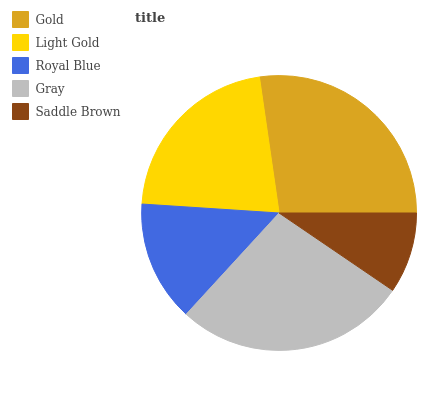Is Saddle Brown the minimum?
Answer yes or no. Yes. Is Gray the maximum?
Answer yes or no. Yes. Is Light Gold the minimum?
Answer yes or no. No. Is Light Gold the maximum?
Answer yes or no. No. Is Gold greater than Light Gold?
Answer yes or no. Yes. Is Light Gold less than Gold?
Answer yes or no. Yes. Is Light Gold greater than Gold?
Answer yes or no. No. Is Gold less than Light Gold?
Answer yes or no. No. Is Light Gold the high median?
Answer yes or no. Yes. Is Light Gold the low median?
Answer yes or no. Yes. Is Saddle Brown the high median?
Answer yes or no. No. Is Royal Blue the low median?
Answer yes or no. No. 